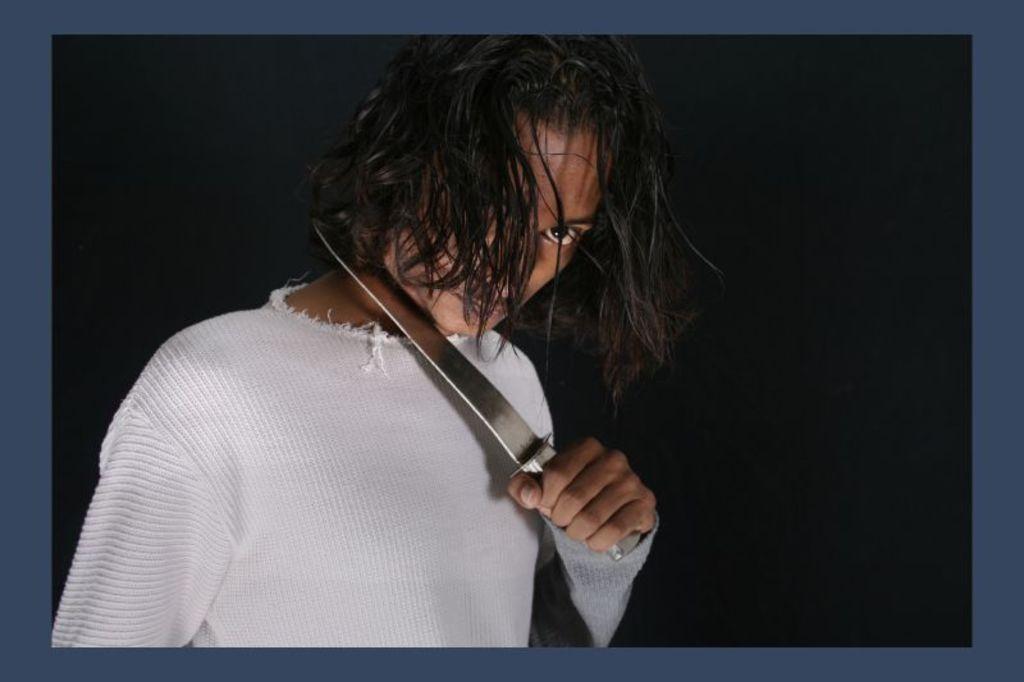Describe this image in one or two sentences. In this picture there is a person holding a knife near his neck and background is black. 